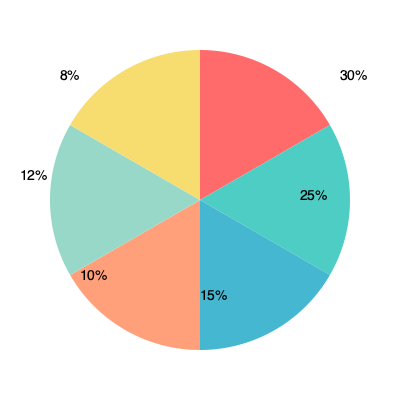The pie chart represents the ethnic composition of a construction team. If the team has 200 members in total, how many more Hispanic workers would need to be hired to increase their representation from 25% to 30% of the team? Let's approach this step-by-step:

1. First, let's calculate the current number of Hispanic workers:
   * Total team members = 200
   * Current Hispanic representation = 25%
   * Current number of Hispanic workers = $200 \times 25\% = 200 \times 0.25 = 50$

2. Now, let's calculate how many Hispanic workers would represent 30% of the team:
   * Desired Hispanic representation = 30%
   * Desired number of Hispanic workers = $200 \times 30\% = 200 \times 0.30 = 60$

3. To find out how many more Hispanic workers need to be hired, we subtract the current number from the desired number:
   * Additional Hispanic workers needed = Desired number - Current number
   * Additional Hispanic workers needed = $60 - 50 = 10$

Therefore, 10 more Hispanic workers would need to be hired to increase their representation from 25% to 30% of the team.
Answer: 10 workers 